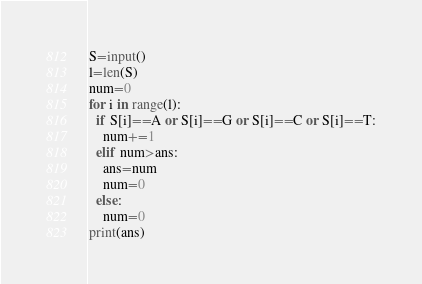<code> <loc_0><loc_0><loc_500><loc_500><_Python_>S=input()
l=len(S)
num=0
for i in range(l):
  if S[i]==A or S[i]==G or S[i]==C or S[i]==T:
    num+=1
  elif num>ans:
    ans=num
    num=0
  else:
    num=0
print(ans)</code> 